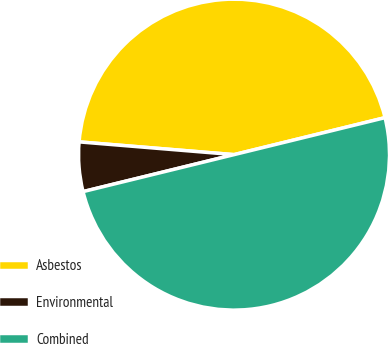Convert chart to OTSL. <chart><loc_0><loc_0><loc_500><loc_500><pie_chart><fcel>Asbestos<fcel>Environmental<fcel>Combined<nl><fcel>44.87%<fcel>5.13%<fcel>50.0%<nl></chart> 